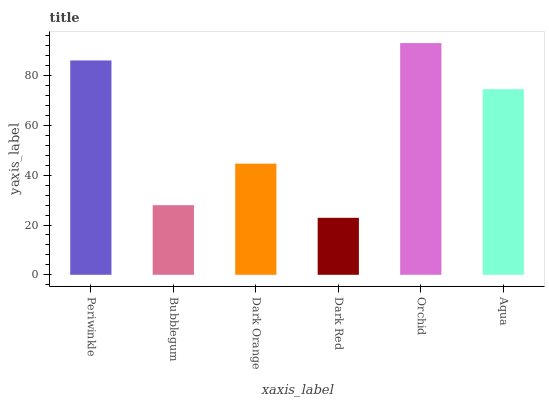Is Dark Red the minimum?
Answer yes or no. Yes. Is Orchid the maximum?
Answer yes or no. Yes. Is Bubblegum the minimum?
Answer yes or no. No. Is Bubblegum the maximum?
Answer yes or no. No. Is Periwinkle greater than Bubblegum?
Answer yes or no. Yes. Is Bubblegum less than Periwinkle?
Answer yes or no. Yes. Is Bubblegum greater than Periwinkle?
Answer yes or no. No. Is Periwinkle less than Bubblegum?
Answer yes or no. No. Is Aqua the high median?
Answer yes or no. Yes. Is Dark Orange the low median?
Answer yes or no. Yes. Is Periwinkle the high median?
Answer yes or no. No. Is Orchid the low median?
Answer yes or no. No. 